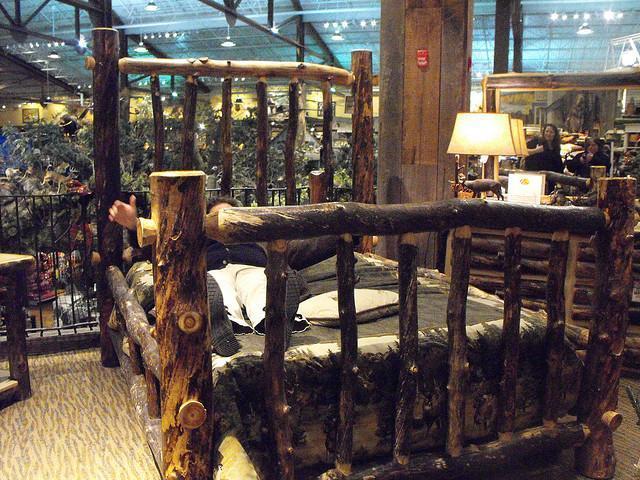How many beds can you see?
Give a very brief answer. 1. 